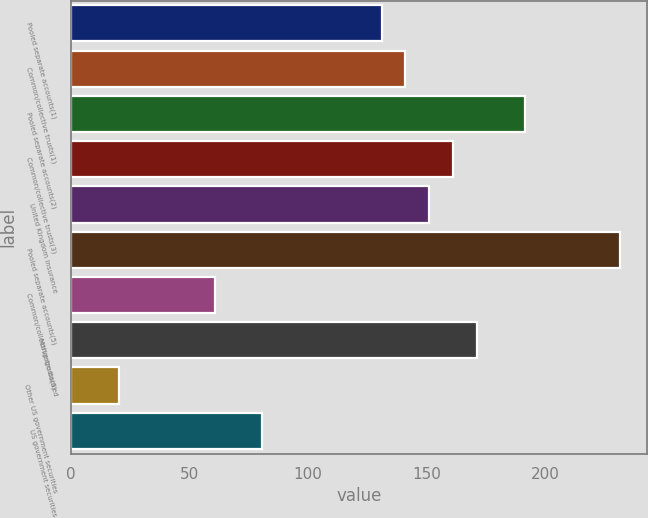Convert chart to OTSL. <chart><loc_0><loc_0><loc_500><loc_500><bar_chart><fcel>Pooled separate accounts(1)<fcel>Common/collective trusts(1)<fcel>Pooled separate accounts(2)<fcel>Common/collective trusts(3)<fcel>United Kingdom insurance<fcel>Pooled separate accounts(5)<fcel>Common/collective trusts(6)<fcel>Mortgage-backed<fcel>Other US government securities<fcel>US government securities<nl><fcel>131.14<fcel>141.19<fcel>191.44<fcel>161.29<fcel>151.24<fcel>231.64<fcel>60.79<fcel>171.34<fcel>20.59<fcel>80.89<nl></chart> 